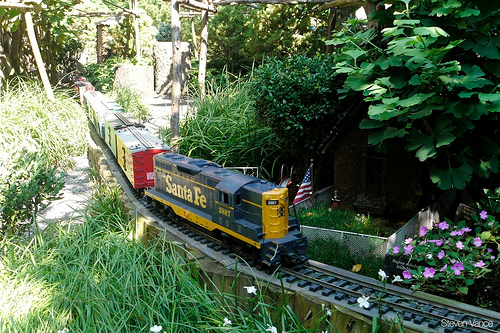Please provide a short description for this region: [0.59, 0.49, 0.63, 0.57]. This region depicts a small American flag next to a train. 